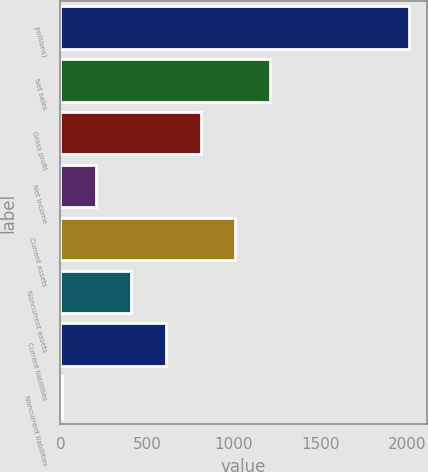Convert chart to OTSL. <chart><loc_0><loc_0><loc_500><loc_500><bar_chart><fcel>(millions)<fcel>Net sales<fcel>Gross profit<fcel>Net income<fcel>Current assets<fcel>Noncurrent assets<fcel>Current liabilities<fcel>Noncurrent liabilities<nl><fcel>2014<fcel>1210.92<fcel>809.38<fcel>207.07<fcel>1010.15<fcel>407.84<fcel>608.61<fcel>6.3<nl></chart> 